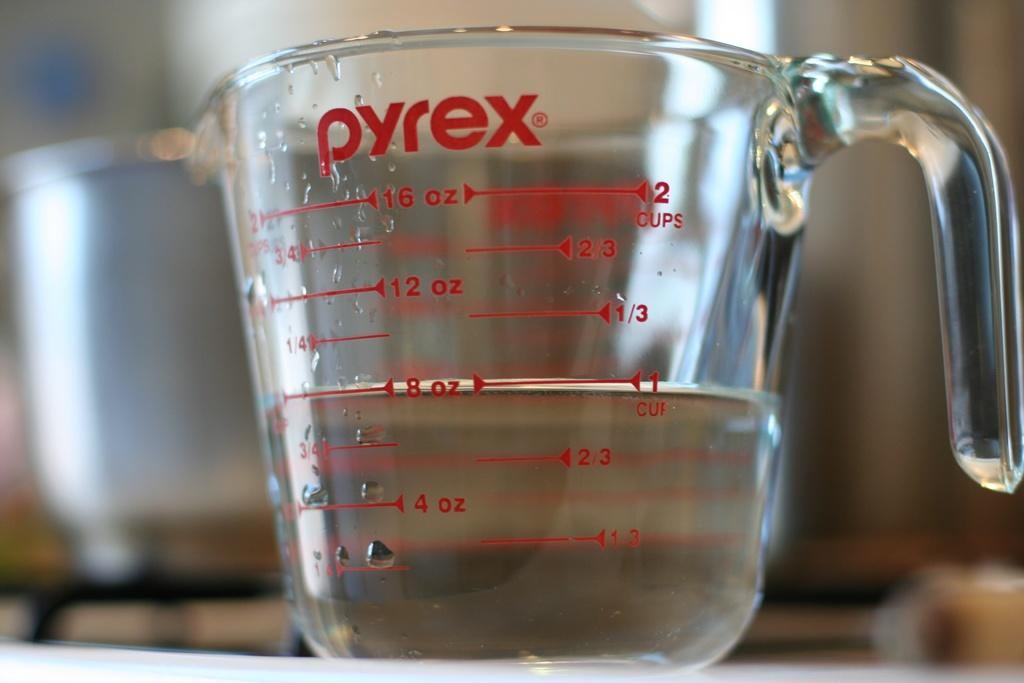Provide a one-sentence caption for the provided image. Clear liquid in a pyrex measuring cup filled half way. 